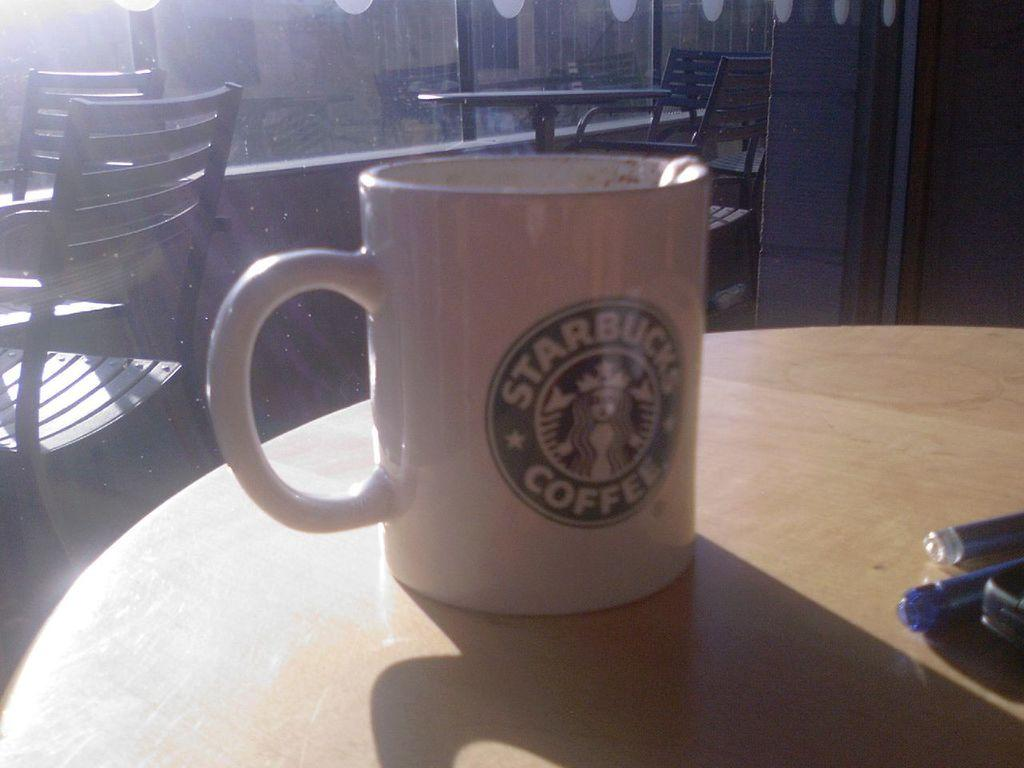<image>
Relay a brief, clear account of the picture shown. A plain white mug with the Starbucks logo on it. 